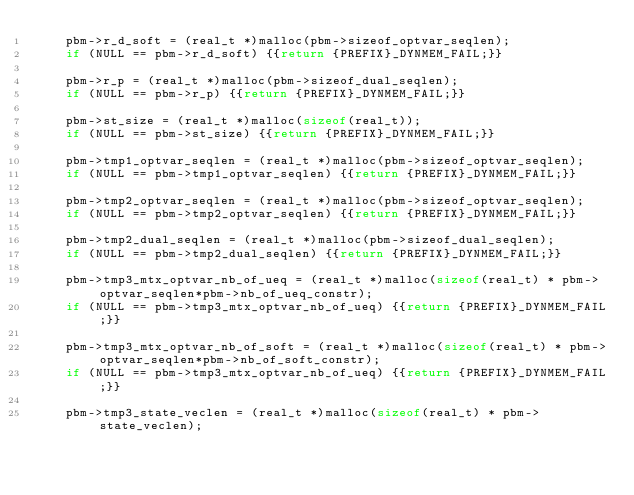<code> <loc_0><loc_0><loc_500><loc_500><_C_>    pbm->r_d_soft = (real_t *)malloc(pbm->sizeof_optvar_seqlen);
    if (NULL == pbm->r_d_soft) {{return {PREFIX}_DYNMEM_FAIL;}}
    
    pbm->r_p = (real_t *)malloc(pbm->sizeof_dual_seqlen);
    if (NULL == pbm->r_p) {{return {PREFIX}_DYNMEM_FAIL;}}
    
    pbm->st_size = (real_t *)malloc(sizeof(real_t));
    if (NULL == pbm->st_size) {{return {PREFIX}_DYNMEM_FAIL;}}
    
    pbm->tmp1_optvar_seqlen = (real_t *)malloc(pbm->sizeof_optvar_seqlen);
    if (NULL == pbm->tmp1_optvar_seqlen) {{return {PREFIX}_DYNMEM_FAIL;}}
    
    pbm->tmp2_optvar_seqlen = (real_t *)malloc(pbm->sizeof_optvar_seqlen);
    if (NULL == pbm->tmp2_optvar_seqlen) {{return {PREFIX}_DYNMEM_FAIL;}}
    
    pbm->tmp2_dual_seqlen = (real_t *)malloc(pbm->sizeof_dual_seqlen);
    if (NULL == pbm->tmp2_dual_seqlen) {{return {PREFIX}_DYNMEM_FAIL;}}
    
    pbm->tmp3_mtx_optvar_nb_of_ueq = (real_t *)malloc(sizeof(real_t) * pbm->optvar_seqlen*pbm->nb_of_ueq_constr);
    if (NULL == pbm->tmp3_mtx_optvar_nb_of_ueq) {{return {PREFIX}_DYNMEM_FAIL;}}
    
    pbm->tmp3_mtx_optvar_nb_of_soft = (real_t *)malloc(sizeof(real_t) * pbm->optvar_seqlen*pbm->nb_of_soft_constr);
    if (NULL == pbm->tmp3_mtx_optvar_nb_of_ueq) {{return {PREFIX}_DYNMEM_FAIL;}}
    
    pbm->tmp3_state_veclen = (real_t *)malloc(sizeof(real_t) * pbm->state_veclen);</code> 